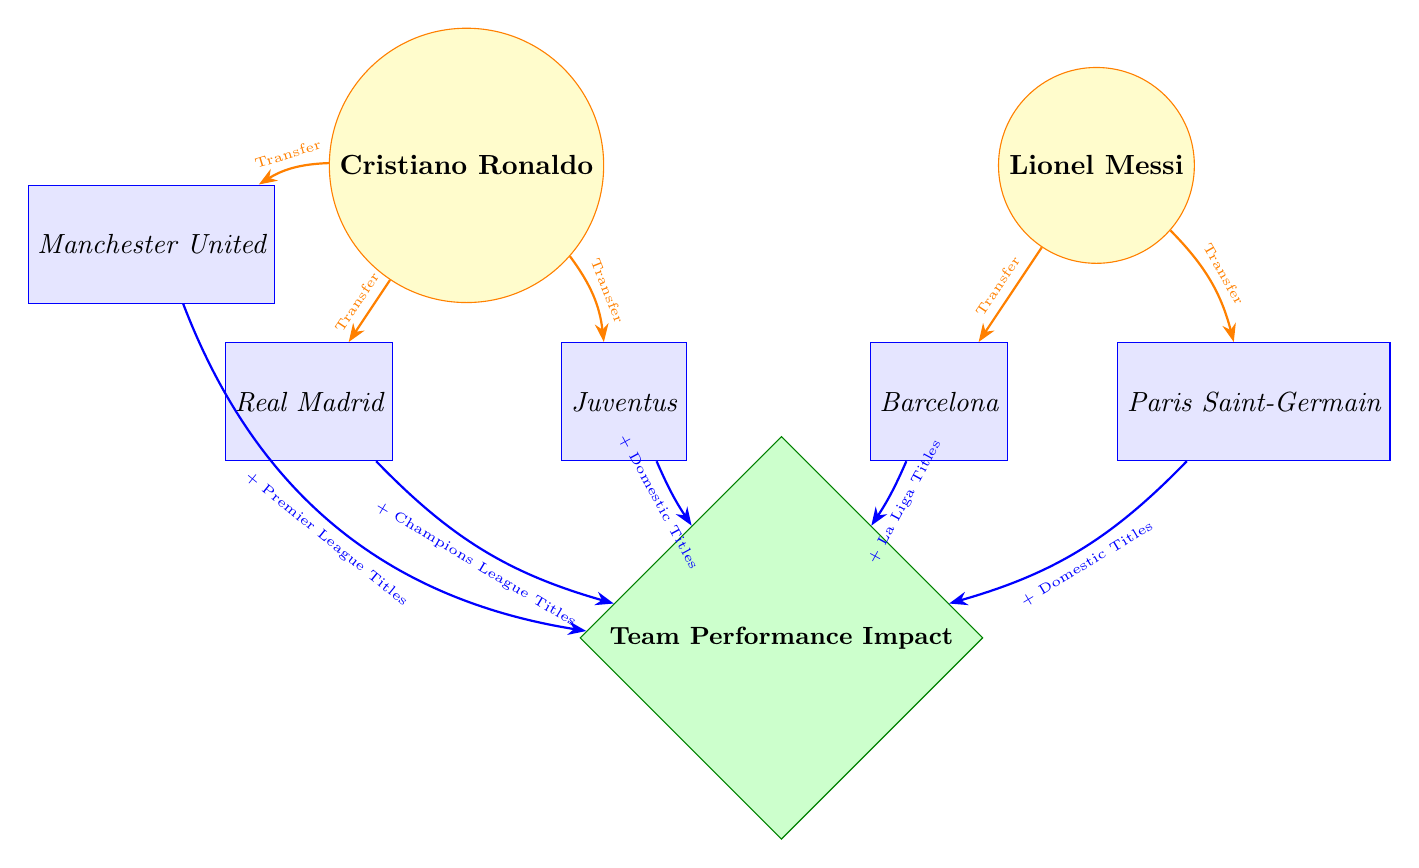What teams did Cristiano Ronaldo transfer to? The diagram shows connections from the player Cristiano Ronaldo to three teams: Manchester United, Real Madrid, and Juventus, represented by edges labeled 'Transfer'. Keeping these in mind gives a clear list of the teams he transferred to.
Answer: Manchester United, Real Madrid, Juventus What titles did Real Madrid gain through player transfers? The edge from Real Madrid to the Team Performance Impact indicates that the club gained + Champions League Titles, making it clear what impact the transfers had on this team specifically.
Answer: + Champions League Titles How many teams are represented in the diagram? Counting the number of nodes labeled as teams visually in the diagram reveals there are five teams: Real Madrid, Manchester United, Juventus, Barcelona, and Paris Saint-Germain.
Answer: 5 Which player transferred to Barcelona? The edge labeled 'Transfer' indicates that Lionel Messi is connected to Barcelona in the diagram, confirming he is the player who transferred to that team.
Answer: Lionel Messi What is the total number of transfers shown in the diagram? By counting the edges from players to teams labeled 'Transfer', a total of five transfers can be identified: Cristiano Ronaldo (3) and Lionel Messi (2). Adding these gives a total of five transfers depicted in the diagram.
Answer: 5 Which team is associated with gaining + Domestic Titles through player transfers? The diagram shows edges from both Juventus and Paris Saint-Germain to the Team Performance Impact with the label '+ Domestic Titles', indicating both clubs have gained this title impact.
Answer: Juventus, Paris Saint-Germain Which player is connected to the most teams in the diagram? By evaluating the number of edges emanating from each player, Cristiano Ronaldo shows connections to three teams (Manchester United, Real Madrid, and Juventus) while Lionel Messi is connected to two teams (Barcelona and Paris Saint-Germain). Thus, this makes Ronaldo the player connected to the most teams.
Answer: Cristiano Ronaldo What do the green diamond nodes represent in the diagram? The green diamond node labeled 'Team Performance Impact' signifies the overall impact of the transfers on team performance, indicating the types of titles won by the respective teams shown.
Answer: Team Performance Impact What connection does Lionel Messi have with Paris Saint-Germain? The edge from Lionel Messi to Paris Saint-Germain is labeled 'Transfer', clearly indicating that it is a transfer to that team, thus establishing their connection in one straightforward label.
Answer: Transfer 